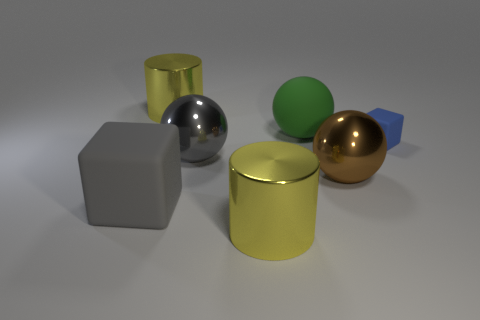Subtract all large metallic spheres. How many spheres are left? 1 Add 2 brown balls. How many objects exist? 9 Subtract all green balls. How many balls are left? 2 Subtract 1 balls. How many balls are left? 2 Subtract all cylinders. How many objects are left? 5 Subtract all brown metal things. Subtract all yellow metal objects. How many objects are left? 4 Add 5 rubber balls. How many rubber balls are left? 6 Add 5 brown metallic spheres. How many brown metallic spheres exist? 6 Subtract 1 green balls. How many objects are left? 6 Subtract all cyan balls. Subtract all brown cylinders. How many balls are left? 3 